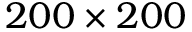<formula> <loc_0><loc_0><loc_500><loc_500>2 0 0 \times 2 0 0</formula> 